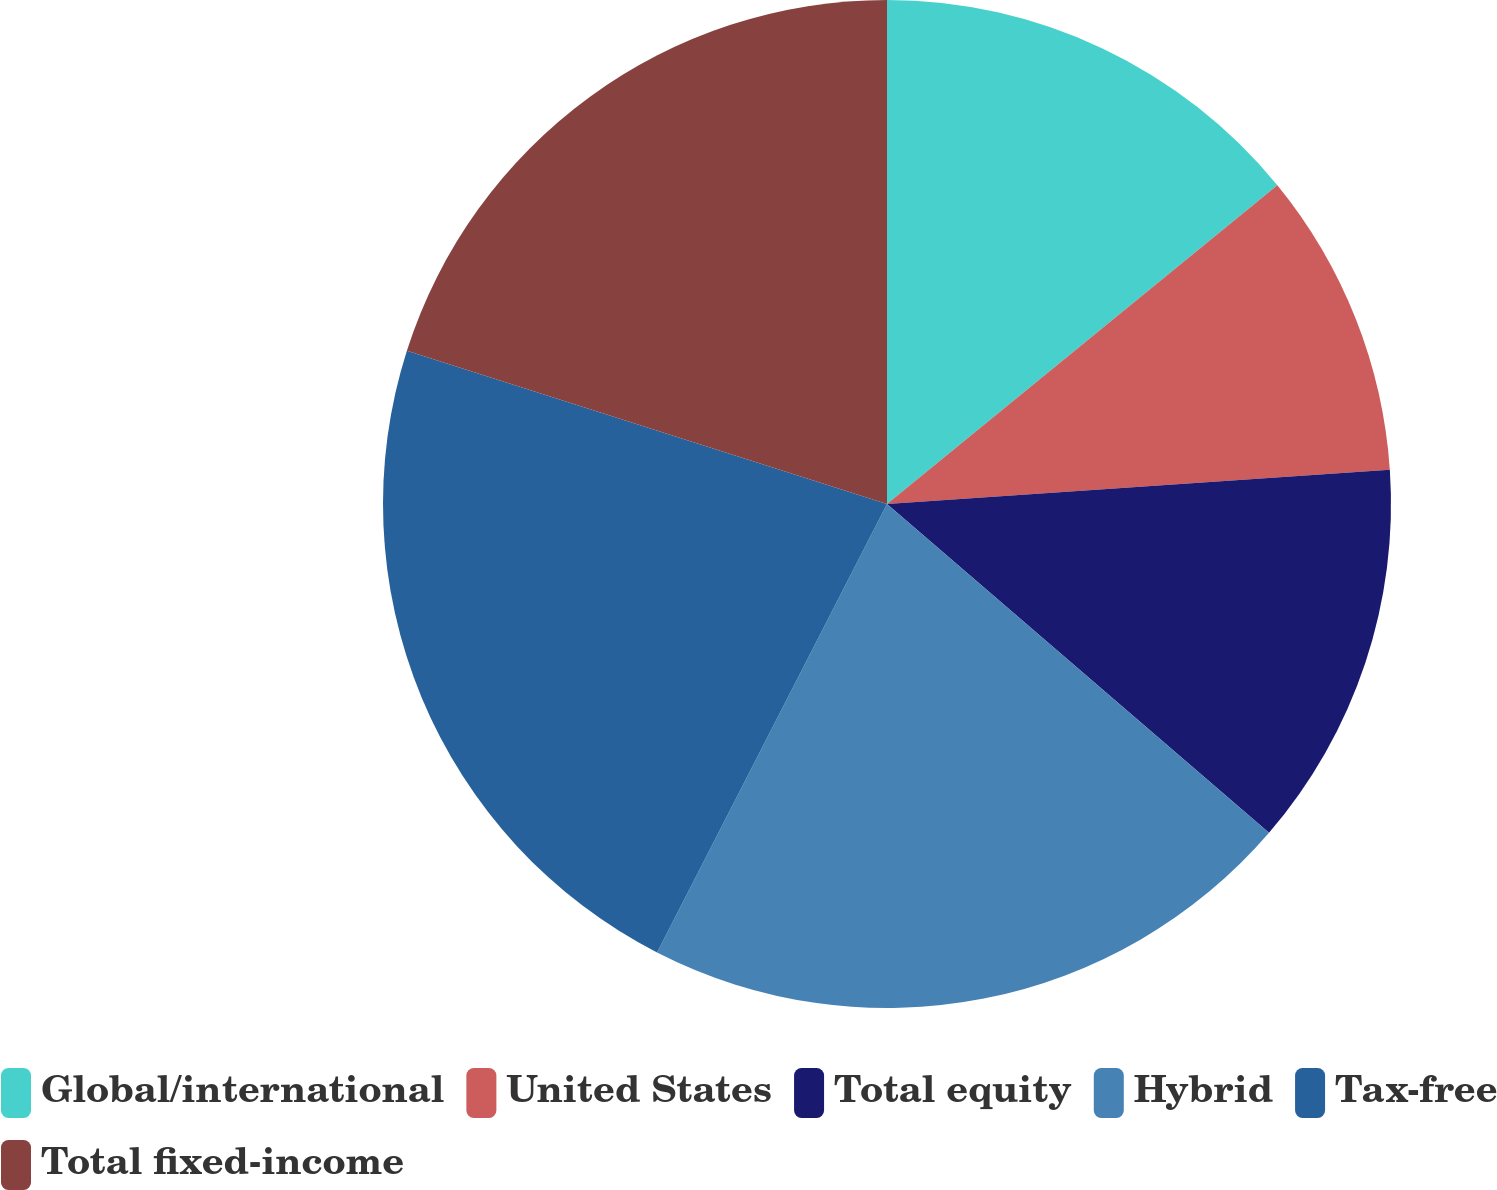Convert chart. <chart><loc_0><loc_0><loc_500><loc_500><pie_chart><fcel>Global/international<fcel>United States<fcel>Total equity<fcel>Hybrid<fcel>Tax-free<fcel>Total fixed-income<nl><fcel>14.1%<fcel>9.82%<fcel>12.39%<fcel>21.23%<fcel>22.38%<fcel>20.08%<nl></chart> 